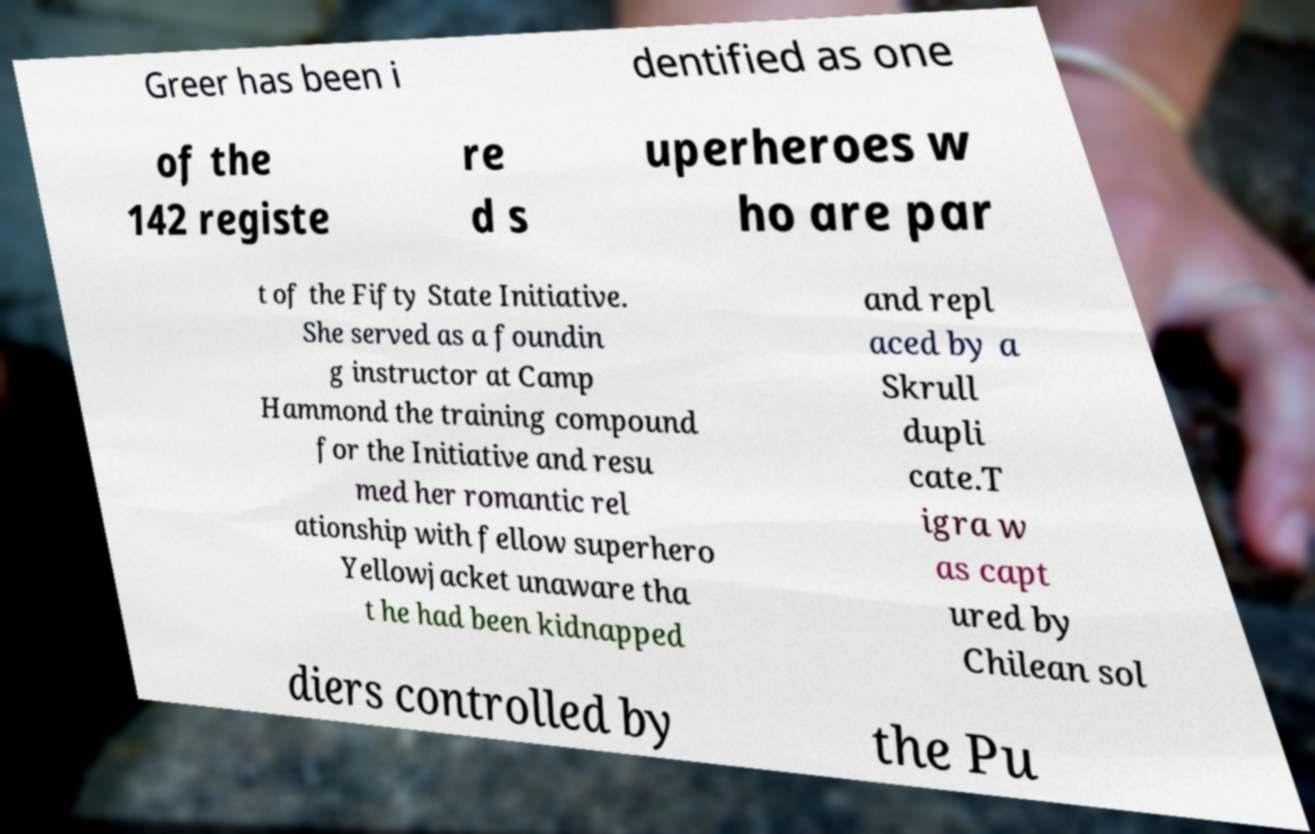Please read and relay the text visible in this image. What does it say? Greer has been i dentified as one of the 142 registe re d s uperheroes w ho are par t of the Fifty State Initiative. She served as a foundin g instructor at Camp Hammond the training compound for the Initiative and resu med her romantic rel ationship with fellow superhero Yellowjacket unaware tha t he had been kidnapped and repl aced by a Skrull dupli cate.T igra w as capt ured by Chilean sol diers controlled by the Pu 